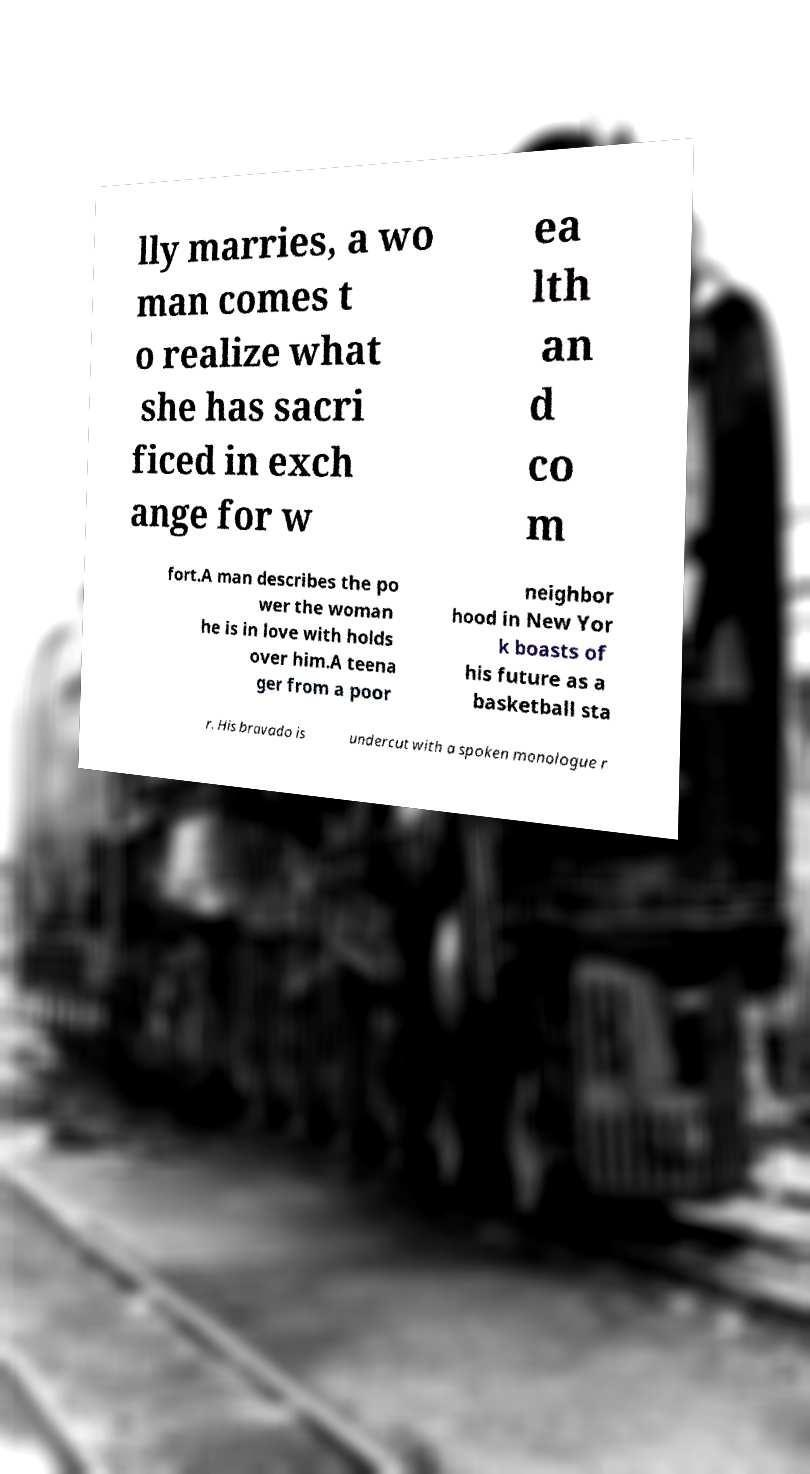Could you assist in decoding the text presented in this image and type it out clearly? lly marries, a wo man comes t o realize what she has sacri ficed in exch ange for w ea lth an d co m fort.A man describes the po wer the woman he is in love with holds over him.A teena ger from a poor neighbor hood in New Yor k boasts of his future as a basketball sta r. His bravado is undercut with a spoken monologue r 